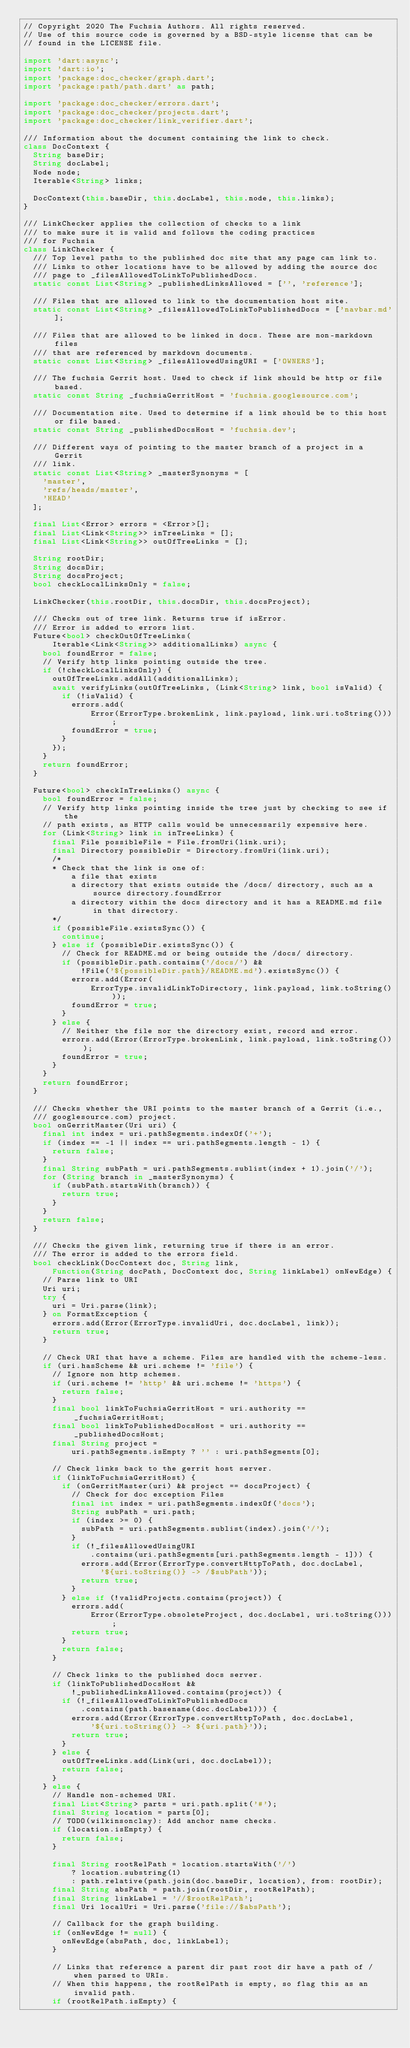Convert code to text. <code><loc_0><loc_0><loc_500><loc_500><_Dart_>// Copyright 2020 The Fuchsia Authors. All rights reserved.
// Use of this source code is governed by a BSD-style license that can be
// found in the LICENSE file.

import 'dart:async';
import 'dart:io';
import 'package:doc_checker/graph.dart';
import 'package:path/path.dart' as path;

import 'package:doc_checker/errors.dart';
import 'package:doc_checker/projects.dart';
import 'package:doc_checker/link_verifier.dart';

/// Information about the document containing the link to check.
class DocContext {
  String baseDir;
  String docLabel;
  Node node;
  Iterable<String> links;

  DocContext(this.baseDir, this.docLabel, this.node, this.links);
}

/// LinkChecker applies the collection of checks to a link
/// to make sure it is valid and follows the coding practices
/// for Fuchsia
class LinkChecker {
  /// Top level paths to the published doc site that any page can link to.
  /// Links to other locations have to be allowed by adding the source doc
  /// page to _filesAllowedToLinkToPublishedDocs.
  static const List<String> _publishedLinksAllowed = ['', 'reference'];

  /// Files that are allowed to link to the documentation host site.
  static const List<String> _filesAllowedToLinkToPublishedDocs = ['navbar.md'];

  /// Files that are allowed to be linked in docs. These are non-markdown files
  /// that are referenced by markdown documents.
  static const List<String> _filesAllowedUsingURI = ['OWNERS'];

  /// The fuchsia Gerrit host. Used to check if link should be http or file based.
  static const String _fuchsiaGerritHost = 'fuchsia.googlesource.com';

  /// Documentation site. Used to determine if a link should be to this host or file based.
  static const String _publishedDocsHost = 'fuchsia.dev';

  /// Different ways of pointing to the master branch of a project in a Gerrit
  /// link.
  static const List<String> _masterSynonyms = [
    'master',
    'refs/heads/master',
    'HEAD'
  ];

  final List<Error> errors = <Error>[];
  final List<Link<String>> inTreeLinks = [];
  final List<Link<String>> outOfTreeLinks = [];

  String rootDir;
  String docsDir;
  String docsProject;
  bool checkLocalLinksOnly = false;

  LinkChecker(this.rootDir, this.docsDir, this.docsProject);

  /// Checks out of tree link. Returns true if isError.
  /// Error is added to errors list.
  Future<bool> checkOutOfTreeLinks(
      Iterable<Link<String>> additionalLinks) async {
    bool foundError = false;
    // Verify http links pointing outside the tree.
    if (!checkLocalLinksOnly) {
      outOfTreeLinks.addAll(additionalLinks);
      await verifyLinks(outOfTreeLinks, (Link<String> link, bool isValid) {
        if (!isValid) {
          errors.add(
              Error(ErrorType.brokenLink, link.payload, link.uri.toString()));
          foundError = true;
        }
      });
    }
    return foundError;
  }

  Future<bool> checkInTreeLinks() async {
    bool foundError = false;
    // Verify http links pointing inside the tree just by checking to see if the
    // path exists, as HTTP calls would be unnecessarily expensive here.
    for (Link<String> link in inTreeLinks) {
      final File possibleFile = File.fromUri(link.uri);
      final Directory possibleDir = Directory.fromUri(link.uri);
      /*
      * Check that the link is one of:
          a file that exists
          a directory that exists outside the /docs/ directory, such as a source directory.foundError
          a directory within the docs directory and it has a README.md file in that directory.
      */
      if (possibleFile.existsSync()) {
        continue;
      } else if (possibleDir.existsSync()) {
        // Check for README.md or being outside the /docs/ directory.
        if (possibleDir.path.contains('/docs/') &&
            !File('${possibleDir.path}/README.md').existsSync()) {
          errors.add(Error(
              ErrorType.invalidLinkToDirectory, link.payload, link.toString()));
          foundError = true;
        }
      } else {
        // Neither the file nor the directory exist, record and error.
        errors.add(Error(ErrorType.brokenLink, link.payload, link.toString()));
        foundError = true;
      }
    }
    return foundError;
  }

  /// Checks whether the URI points to the master branch of a Gerrit (i.e.,
  /// googlesource.com) project.
  bool onGerritMaster(Uri uri) {
    final int index = uri.pathSegments.indexOf('+');
    if (index == -1 || index == uri.pathSegments.length - 1) {
      return false;
    }
    final String subPath = uri.pathSegments.sublist(index + 1).join('/');
    for (String branch in _masterSynonyms) {
      if (subPath.startsWith(branch)) {
        return true;
      }
    }
    return false;
  }

  /// Checks the given link, returning true if there is an error.
  /// The error is added to the errors field.
  bool checkLink(DocContext doc, String link,
      Function(String docPath, DocContext doc, String linkLabel) onNewEdge) {
    // Parse link to URI
    Uri uri;
    try {
      uri = Uri.parse(link);
    } on FormatException {
      errors.add(Error(ErrorType.invalidUri, doc.docLabel, link));
      return true;
    }

    // Check URI that have a scheme. Files are handled with the scheme-less.
    if (uri.hasScheme && uri.scheme != 'file') {
      // Ignore non http schemes.
      if (uri.scheme != 'http' && uri.scheme != 'https') {
        return false;
      }
      final bool linkToFuchsiaGerritHost = uri.authority == _fuchsiaGerritHost;
      final bool linkToPublishedDocsHost = uri.authority == _publishedDocsHost;
      final String project =
          uri.pathSegments.isEmpty ? '' : uri.pathSegments[0];

      // Check links back to the gerrit host server.
      if (linkToFuchsiaGerritHost) {
        if (onGerritMaster(uri) && project == docsProject) {
          // Check for doc exception Files
          final int index = uri.pathSegments.indexOf('docs');
          String subPath = uri.path;
          if (index >= 0) {
            subPath = uri.pathSegments.sublist(index).join('/');
          }
          if (!_filesAllowedUsingURI
              .contains(uri.pathSegments[uri.pathSegments.length - 1])) {
            errors.add(Error(ErrorType.convertHttpToPath, doc.docLabel,
                '${uri.toString()} -> /$subPath'));
            return true;
          }
        } else if (!validProjects.contains(project)) {
          errors.add(
              Error(ErrorType.obsoleteProject, doc.docLabel, uri.toString()));
          return true;
        }
        return false;
      }

      // Check links to the published docs server.
      if (linkToPublishedDocsHost &&
          !_publishedLinksAllowed.contains(project)) {
        if (!_filesAllowedToLinkToPublishedDocs
            .contains(path.basename(doc.docLabel))) {
          errors.add(Error(ErrorType.convertHttpToPath, doc.docLabel,
              '${uri.toString()} -> ${uri.path}'));
          return true;
        }
      } else {
        outOfTreeLinks.add(Link(uri, doc.docLabel));
        return false;
      }
    } else {
      // Handle non-schemed URI.
      final List<String> parts = uri.path.split('#');
      final String location = parts[0];
      // TODO(wilkinsonclay): Add anchor name checks.
      if (location.isEmpty) {
        return false;
      }

      final String rootRelPath = location.startsWith('/')
          ? location.substring(1)
          : path.relative(path.join(doc.baseDir, location), from: rootDir);
      final String absPath = path.join(rootDir, rootRelPath);
      final String linkLabel = '//$rootRelPath';
      final Uri localUri = Uri.parse('file://$absPath');

      // Callback for the graph building.
      if (onNewEdge != null) {
        onNewEdge(absPath, doc, linkLabel);
      }

      // Links that reference a parent dir past root dir have a path of / when parsed to URIs.
      // When this happens, the rootRelPath is empty, so flag this as an invalid path.
      if (rootRelPath.isEmpty) {</code> 